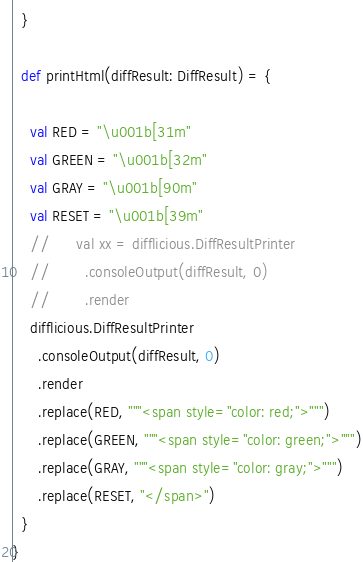Convert code to text. <code><loc_0><loc_0><loc_500><loc_500><_Scala_>  }

  def printHtml(diffResult: DiffResult) = {

    val RED = "\u001b[31m"
    val GREEN = "\u001b[32m"
    val GRAY = "\u001b[90m"
    val RESET = "\u001b[39m"
    //      val xx = difflicious.DiffResultPrinter
    //        .consoleOutput(diffResult, 0)
    //        .render
    difflicious.DiffResultPrinter
      .consoleOutput(diffResult, 0)
      .render
      .replace(RED, """<span style="color: red;">""")
      .replace(GREEN, """<span style="color: green;">""")
      .replace(GRAY, """<span style="color: gray;">""")
      .replace(RESET, "</span>")
  }
}
</code> 